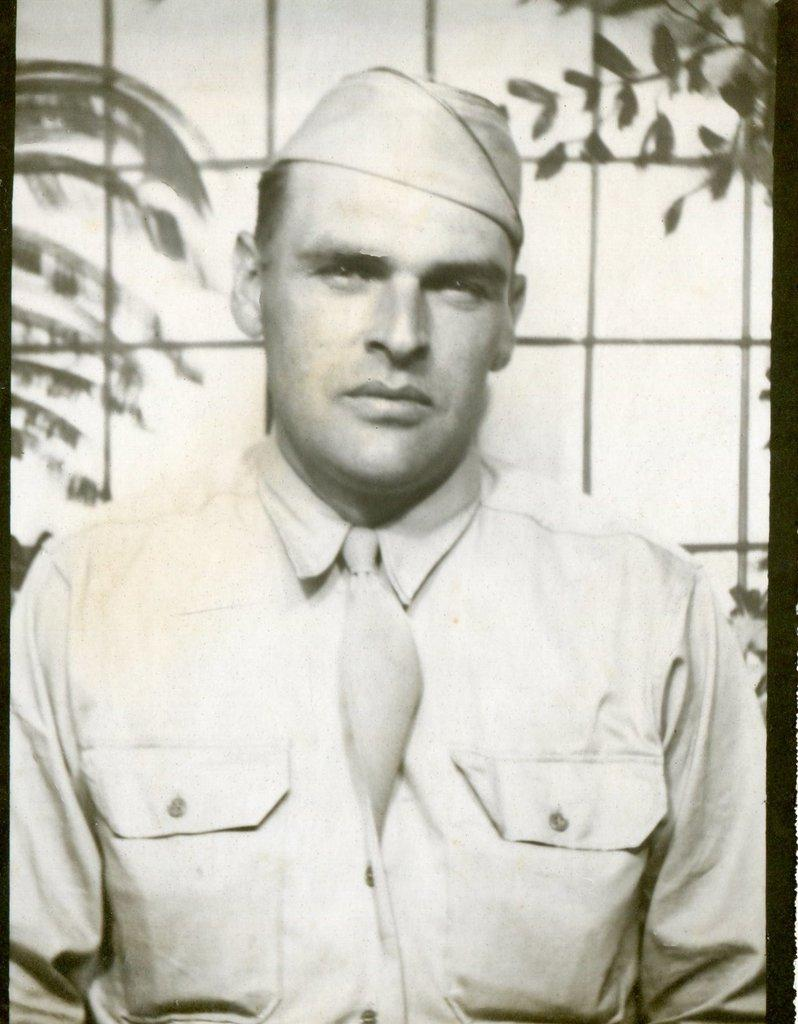What is the main subject in the image? There is a person in the image. What else can be seen in the image besides the person? There are plants in the image. How is the image presented in terms of color? The image is in black and white mode. How many stamps are visible on the person's clothing in the image? There are no stamps visible on the person's clothing in the image, as it is in black and white mode and stamps are typically colorful. 